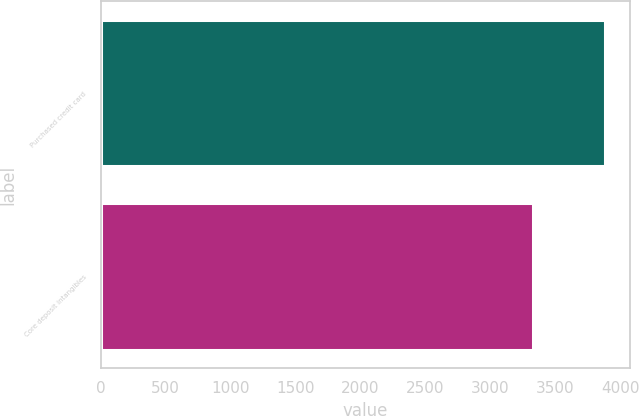<chart> <loc_0><loc_0><loc_500><loc_500><bar_chart><fcel>Purchased credit card<fcel>Core deposit intangibles<nl><fcel>3878<fcel>3328<nl></chart> 